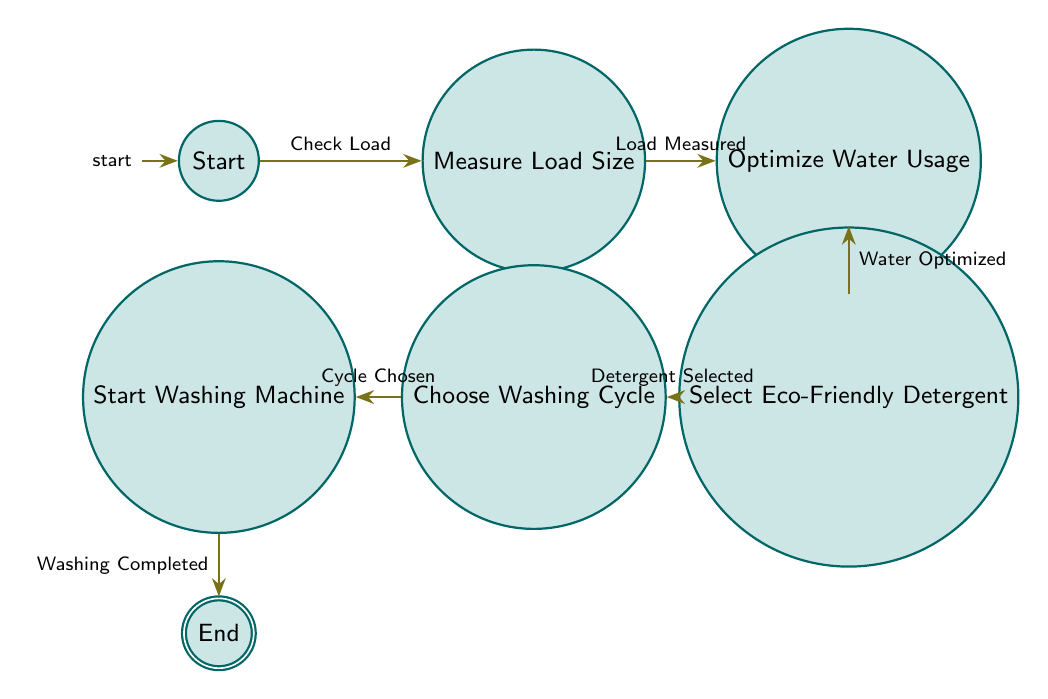What is the initial state of the diagram? The initial state is labeled "Start," which is the entry point of the finite state machine before any actions are taken.
Answer: Start How many total states are in the diagram? The diagram has six states: Start, Measure Load Size, Optimize Water Usage, Select Eco-Friendly Detergent, Choose Washing Cycle, and Start Washing Machine, leading to the End state.
Answer: Six What is the last state in the diagram? The last state represents the conclusion of the laundry process and is labeled "End."
Answer: End What action leads to the "Optimize Water Usage" state? The "Optimize Water Usage" state is reached after measuring the load size, indicated by the input "Load Is Small," "Load Is Medium," or "Load Is Large."
Answer: Load size What input transition occurs after the "Select Eco-Friendly Detergent" state? After selecting an eco-friendly detergent, the transition that follows is "Detergent Selected," leading to the "Choose Washing Cycle" state.
Answer: Detergent Selected Which state is directly linked after "StartWashingMachine"? The state that follows "Start Washing Machine" after washing is completed is the final state, labeled "End."
Answer: End What are the transition inputs for "Measure Load Size"? The inputs for transitioning from "Measure Load Size" to "Optimize Water Usage" are "Load Is Small," "Load Is Medium," and "Load Is Large."
Answer: Load Is Small, Load Is Medium, Load Is Large Which transition leads to "Start Washing Machine"? The transition to "Start Washing Machine" occurs after the input "Cycle Chosen" from the "Choose Washing Cycle" state.
Answer: Cycle Chosen How does water usage get optimized? Water usage is optimized after the measuring of the load size and is indicated by the input "Water Optimized" transitioning to the "Select Eco-Friendly Detergent" state.
Answer: Water Optimized 